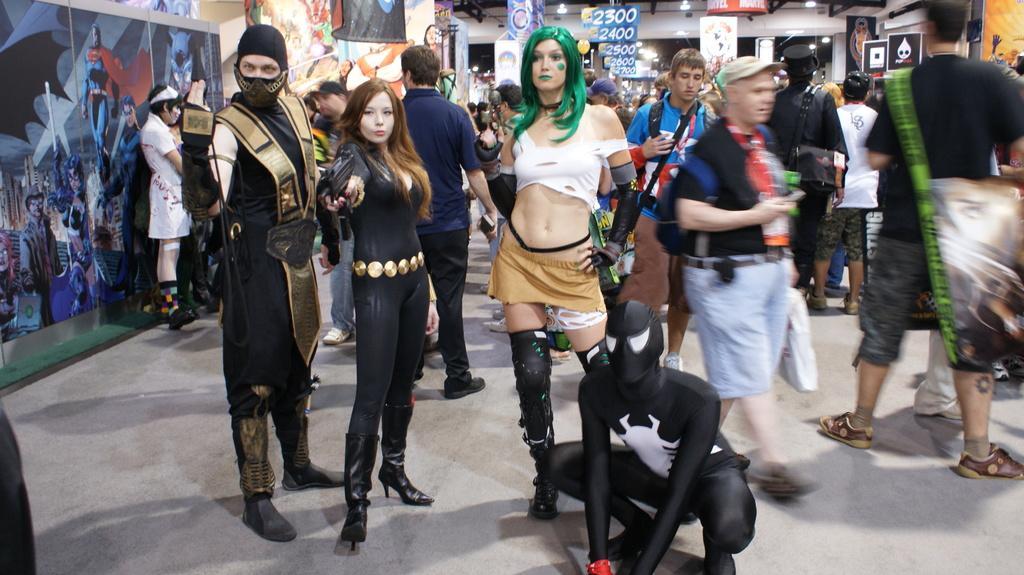In one or two sentences, can you explain what this image depicts? In this image, we can see many people and in the background, there are posters, banners and boards. 